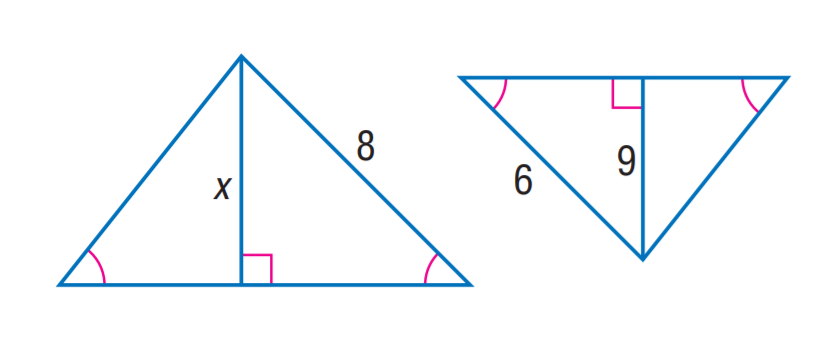Answer the mathemtical geometry problem and directly provide the correct option letter.
Question: Find x.
Choices: A: 6 B: 9 C: 12 D: 15 C 